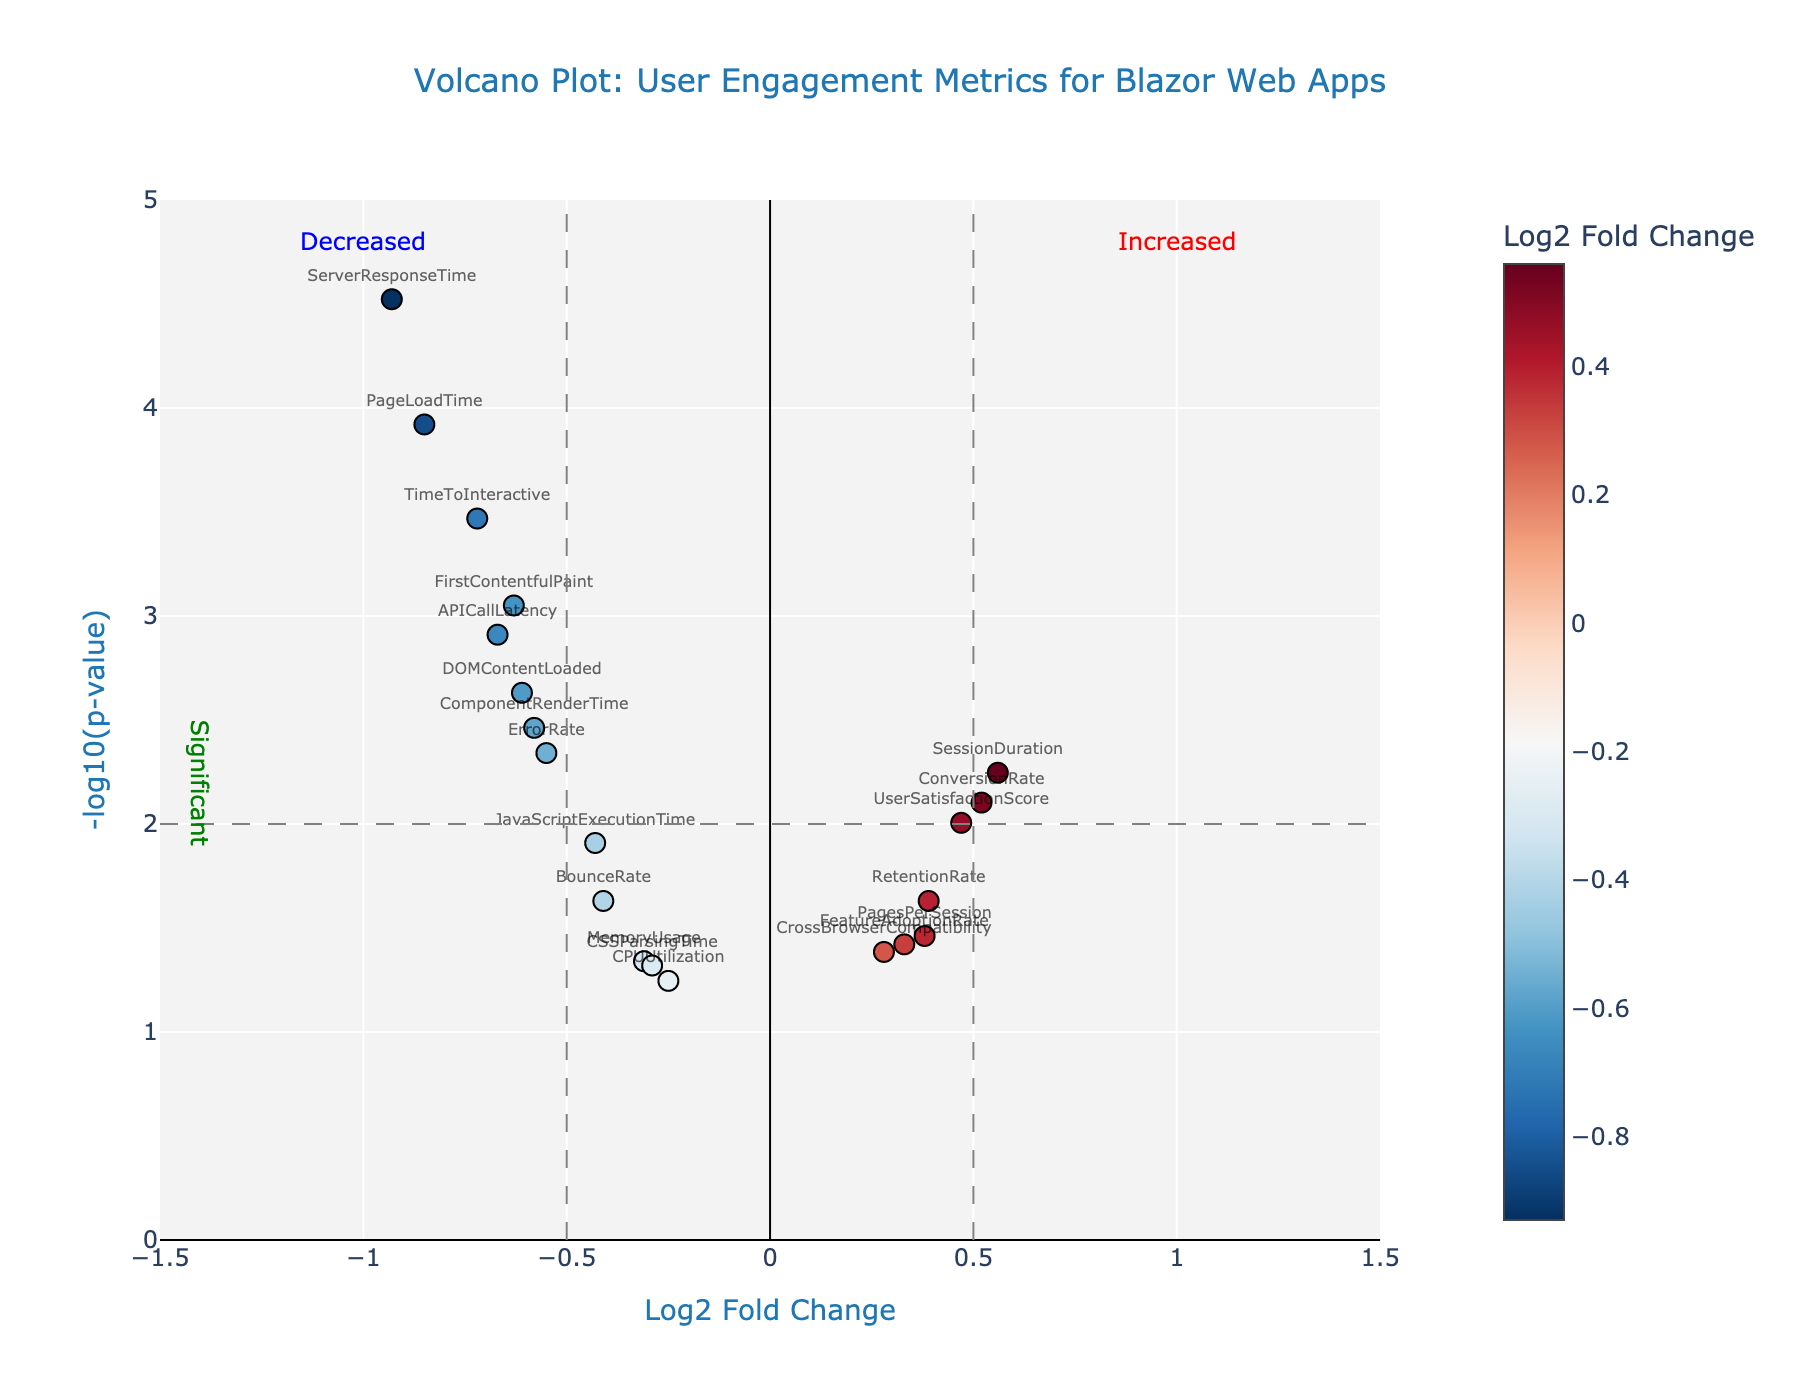What is the title of the plot? The title is located at the top of the plot. It reads "Volcano Plot: User Engagement Metrics for Blazor Web Apps".
Answer: Volcano Plot: User Engagement Metrics for Blazor Web Apps Which metric has the highest statistical significance for improvement? The highest statistical significance is represented by the highest -log10(p-value) and lies in the positive Log2FoldChange direction (right-side). "SessionDuration" has a Log2FoldChange of 0.56 and a notable -log10(p-value).
Answer: SessionDuration What is the total number of features displayed in the plot? The total number of features can be counted by the number of distinct points in the plot. Each point corresponds to one feature.
Answer: 20 Which metric shows the largest decrease in user engagement? The metric with the largest decrease in user engagement has the most negative Log2FoldChange value. "ServerResponseTime" has a Log2FoldChange of -0.93.
Answer: ServerResponseTime List the features that are classified as "statistically significant" based on the plot. A feature is classified as statistically significant if it lies above the horizontal cutoff at -log10(p-value) of 2, and outside the vertical cutoffs at Log2FoldChange of -0.5 and 0.5. The features include:
- PageLoadTime
- TimeToInteractive
- FirstContentfulPaint
- ServerResponseTime
- APICallLatency
- ComponentRenderTime
- DOMContentLoaded
- ErrorRate
Answer: PageLoadTime, TimeToInteractive, FirstContentfulPaint, ServerResponseTime, APICallLatency, ComponentRenderTime, DOMContentLoaded, ErrorRate Which feature has the smallest negative Log2 Fold Change but is still statistically significant? To determine this, we look for the smallest negative Log2FoldChange value above the -log10(p-value) cutoff of 2. "JavaScriptExecutionTime" at -0.43 satisfies this condition.
Answer: JavaScriptExecutionTime What is the general trend of user satisfaction based on the plot? The "UserSatisfactionScore" has a positive Log2FoldChange and lies above the -log10(p-value) of 2, indicating a statistically significant improvement.
Answer: Improvement Which feature with a negative Log2 Fold Change has the least statistical significance? Among features with negative Log2FoldChange, identify the one with the lowest -log10(p-value). "CPUUtilization" has the least statistical significance with a p-value of 0.05678.
Answer: CPUUtilization 